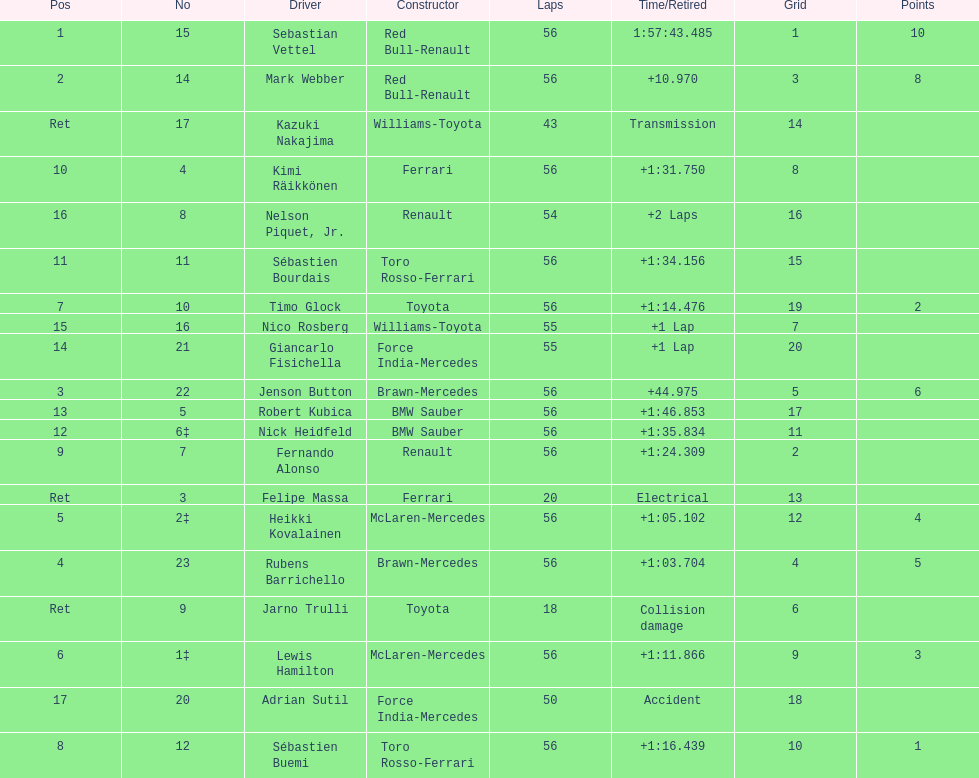What was jenson button's time? +44.975. 